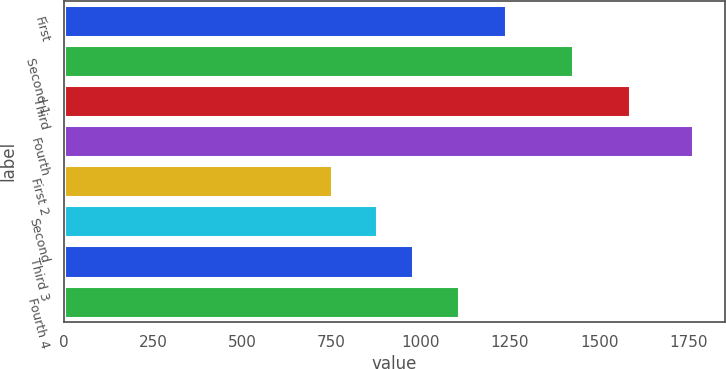Convert chart to OTSL. <chart><loc_0><loc_0><loc_500><loc_500><bar_chart><fcel>First<fcel>Second 1<fcel>Third<fcel>Fourth<fcel>First 2<fcel>Second<fcel>Third 3<fcel>Fourth 4<nl><fcel>1239<fcel>1427<fcel>1585<fcel>1764<fcel>750<fcel>876<fcel>977.4<fcel>1108<nl></chart> 